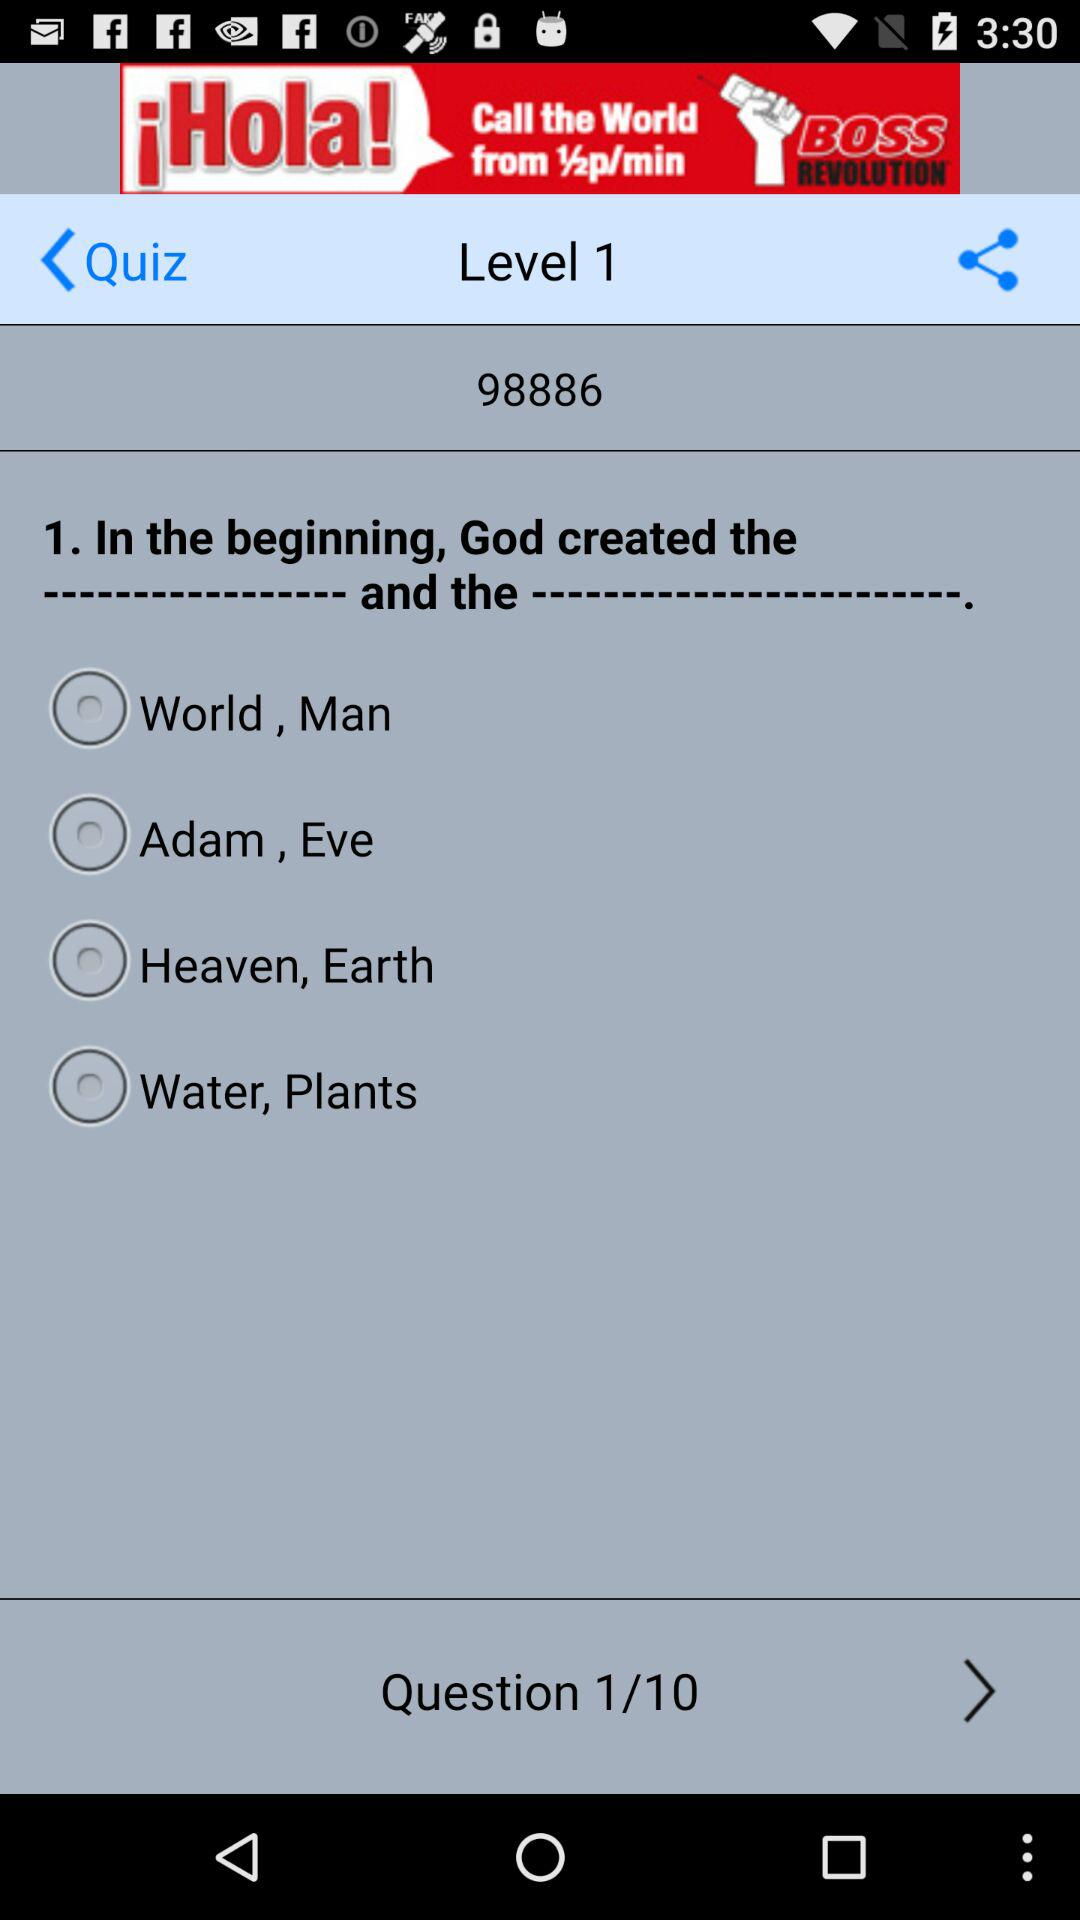What is the level? The level is 1. 